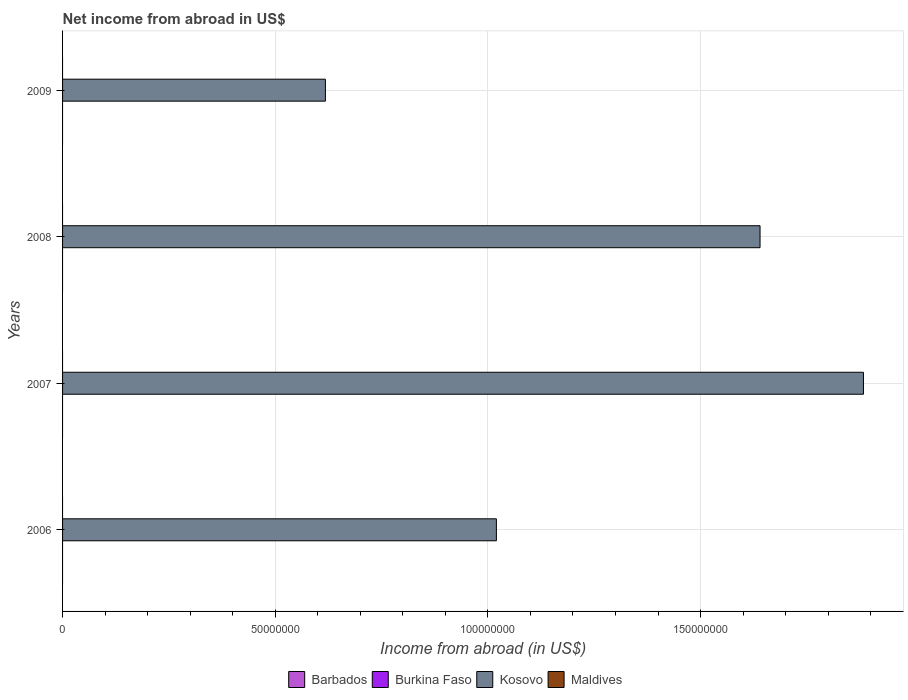How many different coloured bars are there?
Offer a terse response. 1. Are the number of bars per tick equal to the number of legend labels?
Provide a short and direct response. No. Are the number of bars on each tick of the Y-axis equal?
Keep it short and to the point. Yes. How many bars are there on the 4th tick from the top?
Make the answer very short. 1. How many bars are there on the 3rd tick from the bottom?
Keep it short and to the point. 1. What is the label of the 1st group of bars from the top?
Offer a very short reply. 2009. What is the net income from abroad in Burkina Faso in 2007?
Keep it short and to the point. 0. Across all years, what is the maximum net income from abroad in Kosovo?
Offer a terse response. 1.88e+08. Across all years, what is the minimum net income from abroad in Burkina Faso?
Provide a succinct answer. 0. What is the total net income from abroad in Kosovo in the graph?
Your answer should be very brief. 5.16e+08. What is the difference between the net income from abroad in Kosovo in 2006 and that in 2007?
Keep it short and to the point. -8.63e+07. What is the difference between the net income from abroad in Burkina Faso in 2009 and the net income from abroad in Kosovo in 2008?
Your answer should be compact. -1.64e+08. What is the difference between the highest and the second highest net income from abroad in Kosovo?
Your response must be concise. 2.43e+07. What is the difference between the highest and the lowest net income from abroad in Kosovo?
Provide a succinct answer. 1.27e+08. In how many years, is the net income from abroad in Maldives greater than the average net income from abroad in Maldives taken over all years?
Offer a very short reply. 0. Is it the case that in every year, the sum of the net income from abroad in Kosovo and net income from abroad in Burkina Faso is greater than the sum of net income from abroad in Barbados and net income from abroad in Maldives?
Keep it short and to the point. Yes. How many bars are there?
Your response must be concise. 4. Are all the bars in the graph horizontal?
Ensure brevity in your answer.  Yes. Does the graph contain any zero values?
Ensure brevity in your answer.  Yes. Where does the legend appear in the graph?
Your answer should be very brief. Bottom center. What is the title of the graph?
Make the answer very short. Net income from abroad in US$. Does "Montenegro" appear as one of the legend labels in the graph?
Give a very brief answer. No. What is the label or title of the X-axis?
Ensure brevity in your answer.  Income from abroad (in US$). What is the Income from abroad (in US$) in Barbados in 2006?
Keep it short and to the point. 0. What is the Income from abroad (in US$) in Burkina Faso in 2006?
Offer a very short reply. 0. What is the Income from abroad (in US$) in Kosovo in 2006?
Offer a terse response. 1.02e+08. What is the Income from abroad (in US$) of Burkina Faso in 2007?
Your answer should be very brief. 0. What is the Income from abroad (in US$) of Kosovo in 2007?
Offer a very short reply. 1.88e+08. What is the Income from abroad (in US$) in Kosovo in 2008?
Ensure brevity in your answer.  1.64e+08. What is the Income from abroad (in US$) in Maldives in 2008?
Your response must be concise. 0. What is the Income from abroad (in US$) in Barbados in 2009?
Provide a succinct answer. 0. What is the Income from abroad (in US$) of Burkina Faso in 2009?
Keep it short and to the point. 0. What is the Income from abroad (in US$) of Kosovo in 2009?
Your answer should be compact. 6.18e+07. What is the Income from abroad (in US$) of Maldives in 2009?
Provide a succinct answer. 0. Across all years, what is the maximum Income from abroad (in US$) in Kosovo?
Your answer should be very brief. 1.88e+08. Across all years, what is the minimum Income from abroad (in US$) in Kosovo?
Your answer should be very brief. 6.18e+07. What is the total Income from abroad (in US$) in Kosovo in the graph?
Your response must be concise. 5.16e+08. What is the total Income from abroad (in US$) of Maldives in the graph?
Ensure brevity in your answer.  0. What is the difference between the Income from abroad (in US$) in Kosovo in 2006 and that in 2007?
Ensure brevity in your answer.  -8.63e+07. What is the difference between the Income from abroad (in US$) of Kosovo in 2006 and that in 2008?
Offer a very short reply. -6.20e+07. What is the difference between the Income from abroad (in US$) of Kosovo in 2006 and that in 2009?
Give a very brief answer. 4.02e+07. What is the difference between the Income from abroad (in US$) of Kosovo in 2007 and that in 2008?
Offer a terse response. 2.43e+07. What is the difference between the Income from abroad (in US$) of Kosovo in 2007 and that in 2009?
Your answer should be compact. 1.27e+08. What is the difference between the Income from abroad (in US$) in Kosovo in 2008 and that in 2009?
Ensure brevity in your answer.  1.02e+08. What is the average Income from abroad (in US$) of Kosovo per year?
Your answer should be compact. 1.29e+08. What is the average Income from abroad (in US$) of Maldives per year?
Your answer should be very brief. 0. What is the ratio of the Income from abroad (in US$) of Kosovo in 2006 to that in 2007?
Provide a succinct answer. 0.54. What is the ratio of the Income from abroad (in US$) of Kosovo in 2006 to that in 2008?
Keep it short and to the point. 0.62. What is the ratio of the Income from abroad (in US$) of Kosovo in 2006 to that in 2009?
Your response must be concise. 1.65. What is the ratio of the Income from abroad (in US$) in Kosovo in 2007 to that in 2008?
Offer a terse response. 1.15. What is the ratio of the Income from abroad (in US$) of Kosovo in 2007 to that in 2009?
Your answer should be very brief. 3.05. What is the ratio of the Income from abroad (in US$) in Kosovo in 2008 to that in 2009?
Your answer should be compact. 2.65. What is the difference between the highest and the second highest Income from abroad (in US$) in Kosovo?
Offer a very short reply. 2.43e+07. What is the difference between the highest and the lowest Income from abroad (in US$) in Kosovo?
Offer a very short reply. 1.27e+08. 